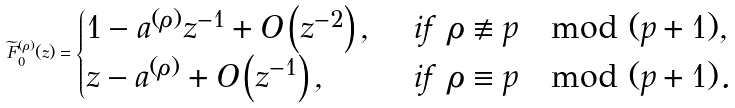<formula> <loc_0><loc_0><loc_500><loc_500>\widetilde { F } _ { 0 } ^ { ( \rho ) } ( z ) = \begin{cases} 1 - a ^ { ( \rho ) } z ^ { - 1 } + O \left ( z ^ { - 2 } \right ) , & \ i f \ \rho \not \equiv p \mod ( p + 1 ) , \\ z - a ^ { ( \rho ) } + O \left ( z ^ { - 1 } \right ) , & \ i f \ \rho \equiv p \mod ( p + 1 ) . \end{cases}</formula> 